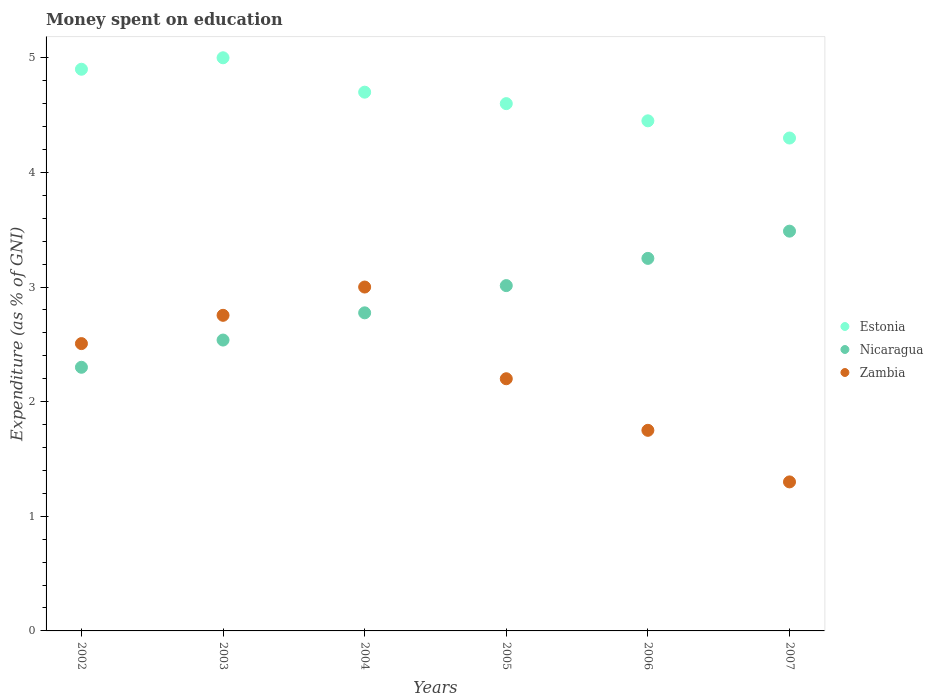How many different coloured dotlines are there?
Your response must be concise. 3. Is the number of dotlines equal to the number of legend labels?
Give a very brief answer. Yes. Across all years, what is the maximum amount of money spent on education in Zambia?
Your answer should be compact. 3. Across all years, what is the minimum amount of money spent on education in Zambia?
Keep it short and to the point. 1.3. In which year was the amount of money spent on education in Nicaragua maximum?
Provide a short and direct response. 2007. What is the total amount of money spent on education in Zambia in the graph?
Provide a succinct answer. 13.51. What is the difference between the amount of money spent on education in Zambia in 2005 and that in 2007?
Give a very brief answer. 0.9. What is the average amount of money spent on education in Zambia per year?
Your answer should be compact. 2.25. In the year 2006, what is the difference between the amount of money spent on education in Estonia and amount of money spent on education in Zambia?
Give a very brief answer. 2.7. In how many years, is the amount of money spent on education in Zambia greater than 0.6000000000000001 %?
Give a very brief answer. 6. What is the ratio of the amount of money spent on education in Zambia in 2003 to that in 2005?
Keep it short and to the point. 1.25. What is the difference between the highest and the second highest amount of money spent on education in Nicaragua?
Make the answer very short. 0.24. What is the difference between the highest and the lowest amount of money spent on education in Estonia?
Keep it short and to the point. 0.7. Does the amount of money spent on education in Zambia monotonically increase over the years?
Your answer should be very brief. No. Is the amount of money spent on education in Nicaragua strictly less than the amount of money spent on education in Estonia over the years?
Your answer should be compact. Yes. How many dotlines are there?
Provide a short and direct response. 3. How many years are there in the graph?
Your answer should be very brief. 6. Are the values on the major ticks of Y-axis written in scientific E-notation?
Provide a succinct answer. No. Does the graph contain grids?
Give a very brief answer. No. How many legend labels are there?
Offer a very short reply. 3. How are the legend labels stacked?
Your answer should be very brief. Vertical. What is the title of the graph?
Your answer should be compact. Money spent on education. What is the label or title of the X-axis?
Make the answer very short. Years. What is the label or title of the Y-axis?
Your answer should be compact. Expenditure (as % of GNI). What is the Expenditure (as % of GNI) of Zambia in 2002?
Provide a succinct answer. 2.51. What is the Expenditure (as % of GNI) in Estonia in 2003?
Ensure brevity in your answer.  5. What is the Expenditure (as % of GNI) of Nicaragua in 2003?
Offer a terse response. 2.54. What is the Expenditure (as % of GNI) in Zambia in 2003?
Keep it short and to the point. 2.75. What is the Expenditure (as % of GNI) in Estonia in 2004?
Provide a short and direct response. 4.7. What is the Expenditure (as % of GNI) of Nicaragua in 2004?
Your response must be concise. 2.78. What is the Expenditure (as % of GNI) of Zambia in 2004?
Your answer should be compact. 3. What is the Expenditure (as % of GNI) of Estonia in 2005?
Give a very brief answer. 4.6. What is the Expenditure (as % of GNI) in Nicaragua in 2005?
Ensure brevity in your answer.  3.01. What is the Expenditure (as % of GNI) of Zambia in 2005?
Keep it short and to the point. 2.2. What is the Expenditure (as % of GNI) of Estonia in 2006?
Your response must be concise. 4.45. What is the Expenditure (as % of GNI) in Nicaragua in 2006?
Your response must be concise. 3.25. What is the Expenditure (as % of GNI) of Zambia in 2006?
Offer a terse response. 1.75. What is the Expenditure (as % of GNI) of Estonia in 2007?
Your response must be concise. 4.3. What is the Expenditure (as % of GNI) of Nicaragua in 2007?
Provide a succinct answer. 3.49. What is the Expenditure (as % of GNI) in Zambia in 2007?
Your answer should be compact. 1.3. Across all years, what is the maximum Expenditure (as % of GNI) of Estonia?
Ensure brevity in your answer.  5. Across all years, what is the maximum Expenditure (as % of GNI) of Nicaragua?
Ensure brevity in your answer.  3.49. Across all years, what is the maximum Expenditure (as % of GNI) of Zambia?
Offer a very short reply. 3. Across all years, what is the minimum Expenditure (as % of GNI) in Nicaragua?
Give a very brief answer. 2.3. What is the total Expenditure (as % of GNI) in Estonia in the graph?
Offer a terse response. 27.95. What is the total Expenditure (as % of GNI) in Nicaragua in the graph?
Your answer should be compact. 17.36. What is the total Expenditure (as % of GNI) in Zambia in the graph?
Your response must be concise. 13.51. What is the difference between the Expenditure (as % of GNI) of Nicaragua in 2002 and that in 2003?
Make the answer very short. -0.24. What is the difference between the Expenditure (as % of GNI) in Zambia in 2002 and that in 2003?
Your answer should be very brief. -0.25. What is the difference between the Expenditure (as % of GNI) in Estonia in 2002 and that in 2004?
Make the answer very short. 0.2. What is the difference between the Expenditure (as % of GNI) in Nicaragua in 2002 and that in 2004?
Make the answer very short. -0.47. What is the difference between the Expenditure (as % of GNI) of Zambia in 2002 and that in 2004?
Your response must be concise. -0.49. What is the difference between the Expenditure (as % of GNI) of Estonia in 2002 and that in 2005?
Keep it short and to the point. 0.3. What is the difference between the Expenditure (as % of GNI) of Nicaragua in 2002 and that in 2005?
Provide a succinct answer. -0.71. What is the difference between the Expenditure (as % of GNI) in Zambia in 2002 and that in 2005?
Your answer should be very brief. 0.31. What is the difference between the Expenditure (as % of GNI) of Estonia in 2002 and that in 2006?
Offer a very short reply. 0.45. What is the difference between the Expenditure (as % of GNI) of Nicaragua in 2002 and that in 2006?
Offer a terse response. -0.95. What is the difference between the Expenditure (as % of GNI) in Zambia in 2002 and that in 2006?
Give a very brief answer. 0.76. What is the difference between the Expenditure (as % of GNI) in Estonia in 2002 and that in 2007?
Your answer should be very brief. 0.6. What is the difference between the Expenditure (as % of GNI) in Nicaragua in 2002 and that in 2007?
Your response must be concise. -1.19. What is the difference between the Expenditure (as % of GNI) in Zambia in 2002 and that in 2007?
Provide a succinct answer. 1.21. What is the difference between the Expenditure (as % of GNI) of Estonia in 2003 and that in 2004?
Your response must be concise. 0.3. What is the difference between the Expenditure (as % of GNI) in Nicaragua in 2003 and that in 2004?
Offer a very short reply. -0.24. What is the difference between the Expenditure (as % of GNI) of Zambia in 2003 and that in 2004?
Ensure brevity in your answer.  -0.25. What is the difference between the Expenditure (as % of GNI) in Estonia in 2003 and that in 2005?
Offer a terse response. 0.4. What is the difference between the Expenditure (as % of GNI) of Nicaragua in 2003 and that in 2005?
Offer a very short reply. -0.47. What is the difference between the Expenditure (as % of GNI) in Zambia in 2003 and that in 2005?
Provide a succinct answer. 0.55. What is the difference between the Expenditure (as % of GNI) of Estonia in 2003 and that in 2006?
Ensure brevity in your answer.  0.55. What is the difference between the Expenditure (as % of GNI) in Nicaragua in 2003 and that in 2006?
Give a very brief answer. -0.71. What is the difference between the Expenditure (as % of GNI) of Estonia in 2003 and that in 2007?
Your response must be concise. 0.7. What is the difference between the Expenditure (as % of GNI) of Nicaragua in 2003 and that in 2007?
Ensure brevity in your answer.  -0.95. What is the difference between the Expenditure (as % of GNI) of Zambia in 2003 and that in 2007?
Ensure brevity in your answer.  1.45. What is the difference between the Expenditure (as % of GNI) of Nicaragua in 2004 and that in 2005?
Offer a very short reply. -0.24. What is the difference between the Expenditure (as % of GNI) of Nicaragua in 2004 and that in 2006?
Ensure brevity in your answer.  -0.47. What is the difference between the Expenditure (as % of GNI) of Estonia in 2004 and that in 2007?
Offer a terse response. 0.4. What is the difference between the Expenditure (as % of GNI) in Nicaragua in 2004 and that in 2007?
Offer a terse response. -0.71. What is the difference between the Expenditure (as % of GNI) in Estonia in 2005 and that in 2006?
Offer a terse response. 0.15. What is the difference between the Expenditure (as % of GNI) of Nicaragua in 2005 and that in 2006?
Your answer should be very brief. -0.24. What is the difference between the Expenditure (as % of GNI) in Zambia in 2005 and that in 2006?
Your answer should be compact. 0.45. What is the difference between the Expenditure (as % of GNI) of Estonia in 2005 and that in 2007?
Provide a short and direct response. 0.3. What is the difference between the Expenditure (as % of GNI) in Nicaragua in 2005 and that in 2007?
Offer a terse response. -0.47. What is the difference between the Expenditure (as % of GNI) in Estonia in 2006 and that in 2007?
Provide a short and direct response. 0.15. What is the difference between the Expenditure (as % of GNI) of Nicaragua in 2006 and that in 2007?
Your answer should be very brief. -0.24. What is the difference between the Expenditure (as % of GNI) in Zambia in 2006 and that in 2007?
Provide a succinct answer. 0.45. What is the difference between the Expenditure (as % of GNI) in Estonia in 2002 and the Expenditure (as % of GNI) in Nicaragua in 2003?
Your answer should be compact. 2.36. What is the difference between the Expenditure (as % of GNI) in Estonia in 2002 and the Expenditure (as % of GNI) in Zambia in 2003?
Your answer should be very brief. 2.15. What is the difference between the Expenditure (as % of GNI) in Nicaragua in 2002 and the Expenditure (as % of GNI) in Zambia in 2003?
Provide a short and direct response. -0.45. What is the difference between the Expenditure (as % of GNI) of Estonia in 2002 and the Expenditure (as % of GNI) of Nicaragua in 2004?
Keep it short and to the point. 2.12. What is the difference between the Expenditure (as % of GNI) in Estonia in 2002 and the Expenditure (as % of GNI) in Nicaragua in 2005?
Provide a succinct answer. 1.89. What is the difference between the Expenditure (as % of GNI) in Estonia in 2002 and the Expenditure (as % of GNI) in Zambia in 2005?
Ensure brevity in your answer.  2.7. What is the difference between the Expenditure (as % of GNI) of Nicaragua in 2002 and the Expenditure (as % of GNI) of Zambia in 2005?
Keep it short and to the point. 0.1. What is the difference between the Expenditure (as % of GNI) in Estonia in 2002 and the Expenditure (as % of GNI) in Nicaragua in 2006?
Offer a terse response. 1.65. What is the difference between the Expenditure (as % of GNI) of Estonia in 2002 and the Expenditure (as % of GNI) of Zambia in 2006?
Offer a very short reply. 3.15. What is the difference between the Expenditure (as % of GNI) of Nicaragua in 2002 and the Expenditure (as % of GNI) of Zambia in 2006?
Offer a terse response. 0.55. What is the difference between the Expenditure (as % of GNI) in Estonia in 2002 and the Expenditure (as % of GNI) in Nicaragua in 2007?
Offer a terse response. 1.41. What is the difference between the Expenditure (as % of GNI) of Estonia in 2002 and the Expenditure (as % of GNI) of Zambia in 2007?
Provide a short and direct response. 3.6. What is the difference between the Expenditure (as % of GNI) in Nicaragua in 2002 and the Expenditure (as % of GNI) in Zambia in 2007?
Make the answer very short. 1. What is the difference between the Expenditure (as % of GNI) in Estonia in 2003 and the Expenditure (as % of GNI) in Nicaragua in 2004?
Your answer should be very brief. 2.23. What is the difference between the Expenditure (as % of GNI) of Nicaragua in 2003 and the Expenditure (as % of GNI) of Zambia in 2004?
Keep it short and to the point. -0.46. What is the difference between the Expenditure (as % of GNI) in Estonia in 2003 and the Expenditure (as % of GNI) in Nicaragua in 2005?
Make the answer very short. 1.99. What is the difference between the Expenditure (as % of GNI) in Nicaragua in 2003 and the Expenditure (as % of GNI) in Zambia in 2005?
Provide a short and direct response. 0.34. What is the difference between the Expenditure (as % of GNI) in Estonia in 2003 and the Expenditure (as % of GNI) in Nicaragua in 2006?
Keep it short and to the point. 1.75. What is the difference between the Expenditure (as % of GNI) in Nicaragua in 2003 and the Expenditure (as % of GNI) in Zambia in 2006?
Provide a succinct answer. 0.79. What is the difference between the Expenditure (as % of GNI) of Estonia in 2003 and the Expenditure (as % of GNI) of Nicaragua in 2007?
Your answer should be compact. 1.51. What is the difference between the Expenditure (as % of GNI) in Nicaragua in 2003 and the Expenditure (as % of GNI) in Zambia in 2007?
Ensure brevity in your answer.  1.24. What is the difference between the Expenditure (as % of GNI) in Estonia in 2004 and the Expenditure (as % of GNI) in Nicaragua in 2005?
Provide a succinct answer. 1.69. What is the difference between the Expenditure (as % of GNI) of Estonia in 2004 and the Expenditure (as % of GNI) of Zambia in 2005?
Provide a short and direct response. 2.5. What is the difference between the Expenditure (as % of GNI) of Nicaragua in 2004 and the Expenditure (as % of GNI) of Zambia in 2005?
Offer a terse response. 0.57. What is the difference between the Expenditure (as % of GNI) in Estonia in 2004 and the Expenditure (as % of GNI) in Nicaragua in 2006?
Ensure brevity in your answer.  1.45. What is the difference between the Expenditure (as % of GNI) of Estonia in 2004 and the Expenditure (as % of GNI) of Zambia in 2006?
Give a very brief answer. 2.95. What is the difference between the Expenditure (as % of GNI) of Estonia in 2004 and the Expenditure (as % of GNI) of Nicaragua in 2007?
Provide a short and direct response. 1.21. What is the difference between the Expenditure (as % of GNI) in Estonia in 2004 and the Expenditure (as % of GNI) in Zambia in 2007?
Give a very brief answer. 3.4. What is the difference between the Expenditure (as % of GNI) of Nicaragua in 2004 and the Expenditure (as % of GNI) of Zambia in 2007?
Offer a terse response. 1.48. What is the difference between the Expenditure (as % of GNI) of Estonia in 2005 and the Expenditure (as % of GNI) of Nicaragua in 2006?
Keep it short and to the point. 1.35. What is the difference between the Expenditure (as % of GNI) of Estonia in 2005 and the Expenditure (as % of GNI) of Zambia in 2006?
Offer a very short reply. 2.85. What is the difference between the Expenditure (as % of GNI) of Nicaragua in 2005 and the Expenditure (as % of GNI) of Zambia in 2006?
Give a very brief answer. 1.26. What is the difference between the Expenditure (as % of GNI) of Estonia in 2005 and the Expenditure (as % of GNI) of Nicaragua in 2007?
Offer a very short reply. 1.11. What is the difference between the Expenditure (as % of GNI) of Nicaragua in 2005 and the Expenditure (as % of GNI) of Zambia in 2007?
Offer a very short reply. 1.71. What is the difference between the Expenditure (as % of GNI) of Estonia in 2006 and the Expenditure (as % of GNI) of Nicaragua in 2007?
Your answer should be compact. 0.96. What is the difference between the Expenditure (as % of GNI) of Estonia in 2006 and the Expenditure (as % of GNI) of Zambia in 2007?
Provide a succinct answer. 3.15. What is the difference between the Expenditure (as % of GNI) of Nicaragua in 2006 and the Expenditure (as % of GNI) of Zambia in 2007?
Provide a succinct answer. 1.95. What is the average Expenditure (as % of GNI) of Estonia per year?
Make the answer very short. 4.66. What is the average Expenditure (as % of GNI) in Nicaragua per year?
Offer a terse response. 2.89. What is the average Expenditure (as % of GNI) of Zambia per year?
Ensure brevity in your answer.  2.25. In the year 2002, what is the difference between the Expenditure (as % of GNI) in Estonia and Expenditure (as % of GNI) in Zambia?
Make the answer very short. 2.39. In the year 2002, what is the difference between the Expenditure (as % of GNI) of Nicaragua and Expenditure (as % of GNI) of Zambia?
Provide a short and direct response. -0.21. In the year 2003, what is the difference between the Expenditure (as % of GNI) in Estonia and Expenditure (as % of GNI) in Nicaragua?
Your answer should be very brief. 2.46. In the year 2003, what is the difference between the Expenditure (as % of GNI) in Estonia and Expenditure (as % of GNI) in Zambia?
Keep it short and to the point. 2.25. In the year 2003, what is the difference between the Expenditure (as % of GNI) in Nicaragua and Expenditure (as % of GNI) in Zambia?
Give a very brief answer. -0.22. In the year 2004, what is the difference between the Expenditure (as % of GNI) of Estonia and Expenditure (as % of GNI) of Nicaragua?
Ensure brevity in your answer.  1.93. In the year 2004, what is the difference between the Expenditure (as % of GNI) of Estonia and Expenditure (as % of GNI) of Zambia?
Provide a short and direct response. 1.7. In the year 2004, what is the difference between the Expenditure (as % of GNI) in Nicaragua and Expenditure (as % of GNI) in Zambia?
Keep it short and to the point. -0.23. In the year 2005, what is the difference between the Expenditure (as % of GNI) of Estonia and Expenditure (as % of GNI) of Nicaragua?
Your response must be concise. 1.59. In the year 2005, what is the difference between the Expenditure (as % of GNI) in Estonia and Expenditure (as % of GNI) in Zambia?
Ensure brevity in your answer.  2.4. In the year 2005, what is the difference between the Expenditure (as % of GNI) in Nicaragua and Expenditure (as % of GNI) in Zambia?
Your answer should be very brief. 0.81. In the year 2006, what is the difference between the Expenditure (as % of GNI) in Estonia and Expenditure (as % of GNI) in Nicaragua?
Keep it short and to the point. 1.2. In the year 2006, what is the difference between the Expenditure (as % of GNI) in Nicaragua and Expenditure (as % of GNI) in Zambia?
Your response must be concise. 1.5. In the year 2007, what is the difference between the Expenditure (as % of GNI) of Estonia and Expenditure (as % of GNI) of Nicaragua?
Give a very brief answer. 0.81. In the year 2007, what is the difference between the Expenditure (as % of GNI) of Estonia and Expenditure (as % of GNI) of Zambia?
Offer a very short reply. 3. In the year 2007, what is the difference between the Expenditure (as % of GNI) in Nicaragua and Expenditure (as % of GNI) in Zambia?
Offer a terse response. 2.19. What is the ratio of the Expenditure (as % of GNI) in Nicaragua in 2002 to that in 2003?
Provide a short and direct response. 0.91. What is the ratio of the Expenditure (as % of GNI) in Zambia in 2002 to that in 2003?
Your response must be concise. 0.91. What is the ratio of the Expenditure (as % of GNI) in Estonia in 2002 to that in 2004?
Your answer should be very brief. 1.04. What is the ratio of the Expenditure (as % of GNI) of Nicaragua in 2002 to that in 2004?
Your answer should be compact. 0.83. What is the ratio of the Expenditure (as % of GNI) in Zambia in 2002 to that in 2004?
Offer a terse response. 0.84. What is the ratio of the Expenditure (as % of GNI) in Estonia in 2002 to that in 2005?
Your response must be concise. 1.07. What is the ratio of the Expenditure (as % of GNI) in Nicaragua in 2002 to that in 2005?
Your answer should be compact. 0.76. What is the ratio of the Expenditure (as % of GNI) of Zambia in 2002 to that in 2005?
Your response must be concise. 1.14. What is the ratio of the Expenditure (as % of GNI) in Estonia in 2002 to that in 2006?
Give a very brief answer. 1.1. What is the ratio of the Expenditure (as % of GNI) of Nicaragua in 2002 to that in 2006?
Keep it short and to the point. 0.71. What is the ratio of the Expenditure (as % of GNI) in Zambia in 2002 to that in 2006?
Keep it short and to the point. 1.43. What is the ratio of the Expenditure (as % of GNI) in Estonia in 2002 to that in 2007?
Ensure brevity in your answer.  1.14. What is the ratio of the Expenditure (as % of GNI) of Nicaragua in 2002 to that in 2007?
Provide a succinct answer. 0.66. What is the ratio of the Expenditure (as % of GNI) of Zambia in 2002 to that in 2007?
Give a very brief answer. 1.93. What is the ratio of the Expenditure (as % of GNI) in Estonia in 2003 to that in 2004?
Offer a terse response. 1.06. What is the ratio of the Expenditure (as % of GNI) in Nicaragua in 2003 to that in 2004?
Offer a very short reply. 0.91. What is the ratio of the Expenditure (as % of GNI) in Zambia in 2003 to that in 2004?
Give a very brief answer. 0.92. What is the ratio of the Expenditure (as % of GNI) in Estonia in 2003 to that in 2005?
Your answer should be very brief. 1.09. What is the ratio of the Expenditure (as % of GNI) of Nicaragua in 2003 to that in 2005?
Provide a succinct answer. 0.84. What is the ratio of the Expenditure (as % of GNI) in Zambia in 2003 to that in 2005?
Make the answer very short. 1.25. What is the ratio of the Expenditure (as % of GNI) in Estonia in 2003 to that in 2006?
Offer a very short reply. 1.12. What is the ratio of the Expenditure (as % of GNI) of Nicaragua in 2003 to that in 2006?
Offer a terse response. 0.78. What is the ratio of the Expenditure (as % of GNI) in Zambia in 2003 to that in 2006?
Keep it short and to the point. 1.57. What is the ratio of the Expenditure (as % of GNI) of Estonia in 2003 to that in 2007?
Ensure brevity in your answer.  1.16. What is the ratio of the Expenditure (as % of GNI) in Nicaragua in 2003 to that in 2007?
Ensure brevity in your answer.  0.73. What is the ratio of the Expenditure (as % of GNI) in Zambia in 2003 to that in 2007?
Keep it short and to the point. 2.12. What is the ratio of the Expenditure (as % of GNI) in Estonia in 2004 to that in 2005?
Provide a short and direct response. 1.02. What is the ratio of the Expenditure (as % of GNI) in Nicaragua in 2004 to that in 2005?
Offer a very short reply. 0.92. What is the ratio of the Expenditure (as % of GNI) in Zambia in 2004 to that in 2005?
Provide a succinct answer. 1.36. What is the ratio of the Expenditure (as % of GNI) in Estonia in 2004 to that in 2006?
Ensure brevity in your answer.  1.06. What is the ratio of the Expenditure (as % of GNI) of Nicaragua in 2004 to that in 2006?
Make the answer very short. 0.85. What is the ratio of the Expenditure (as % of GNI) of Zambia in 2004 to that in 2006?
Make the answer very short. 1.71. What is the ratio of the Expenditure (as % of GNI) of Estonia in 2004 to that in 2007?
Offer a very short reply. 1.09. What is the ratio of the Expenditure (as % of GNI) in Nicaragua in 2004 to that in 2007?
Your answer should be very brief. 0.8. What is the ratio of the Expenditure (as % of GNI) in Zambia in 2004 to that in 2007?
Provide a short and direct response. 2.31. What is the ratio of the Expenditure (as % of GNI) of Estonia in 2005 to that in 2006?
Your answer should be very brief. 1.03. What is the ratio of the Expenditure (as % of GNI) in Nicaragua in 2005 to that in 2006?
Your answer should be compact. 0.93. What is the ratio of the Expenditure (as % of GNI) in Zambia in 2005 to that in 2006?
Your response must be concise. 1.26. What is the ratio of the Expenditure (as % of GNI) of Estonia in 2005 to that in 2007?
Offer a very short reply. 1.07. What is the ratio of the Expenditure (as % of GNI) of Nicaragua in 2005 to that in 2007?
Ensure brevity in your answer.  0.86. What is the ratio of the Expenditure (as % of GNI) in Zambia in 2005 to that in 2007?
Give a very brief answer. 1.69. What is the ratio of the Expenditure (as % of GNI) in Estonia in 2006 to that in 2007?
Offer a terse response. 1.03. What is the ratio of the Expenditure (as % of GNI) in Nicaragua in 2006 to that in 2007?
Offer a very short reply. 0.93. What is the ratio of the Expenditure (as % of GNI) of Zambia in 2006 to that in 2007?
Provide a short and direct response. 1.35. What is the difference between the highest and the second highest Expenditure (as % of GNI) in Nicaragua?
Make the answer very short. 0.24. What is the difference between the highest and the second highest Expenditure (as % of GNI) in Zambia?
Your answer should be compact. 0.25. What is the difference between the highest and the lowest Expenditure (as % of GNI) in Nicaragua?
Your answer should be very brief. 1.19. 